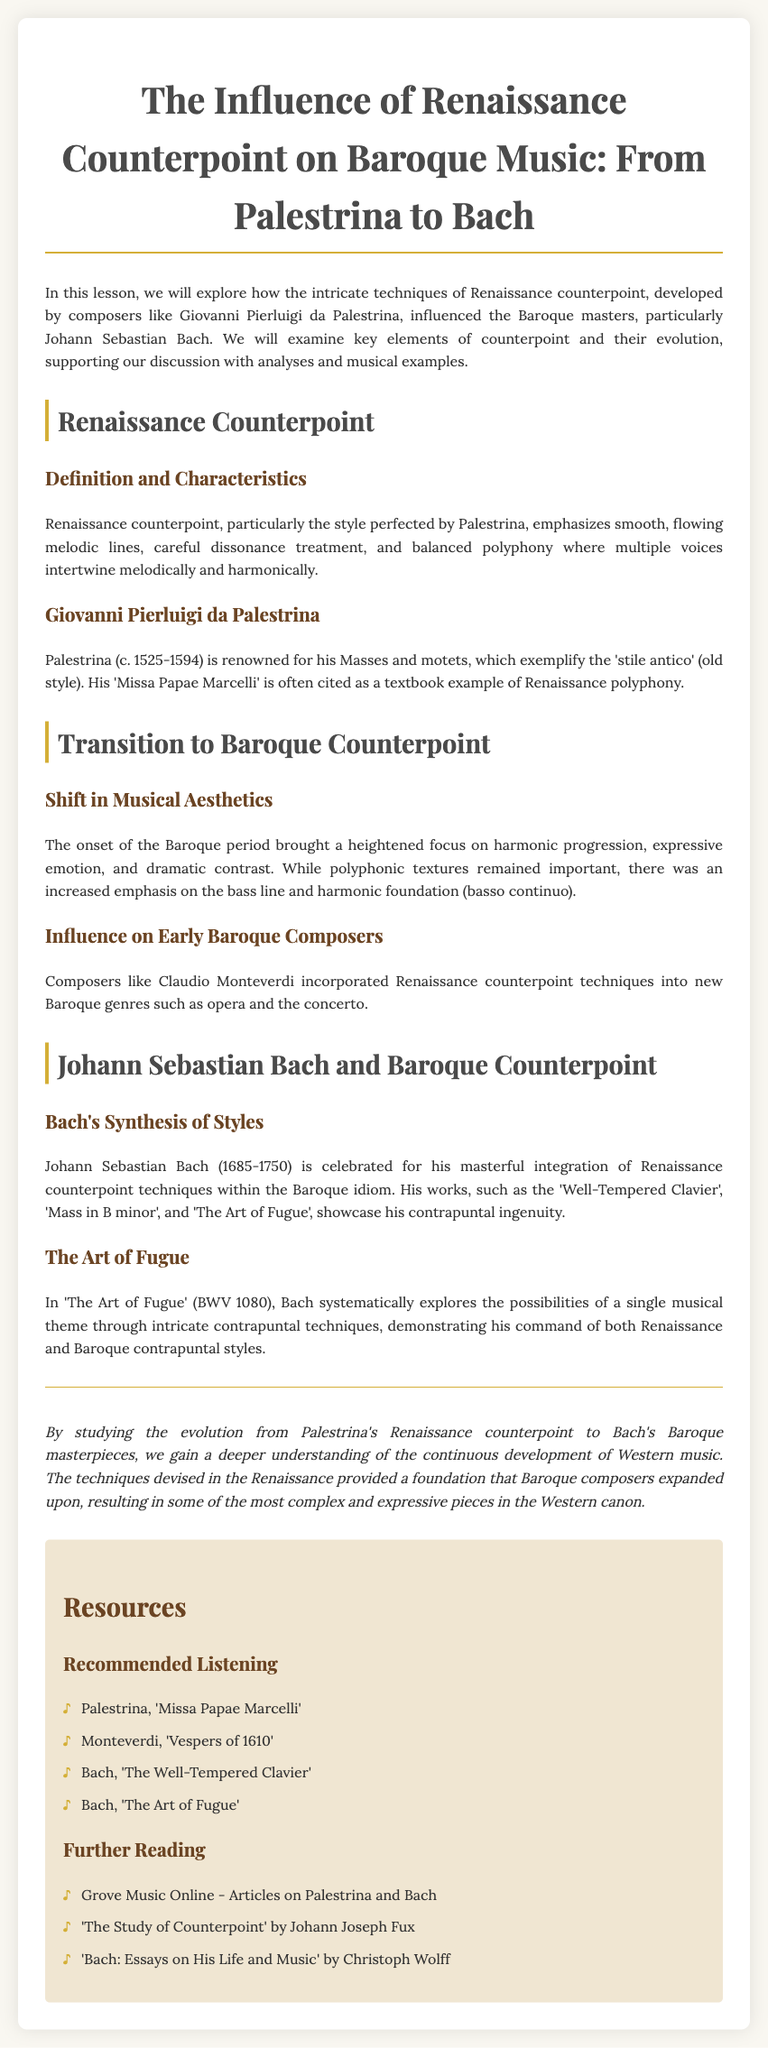What is the title of the lesson? The title of the lesson is provided at the top of the document, which outlines the topic being discussed.
Answer: The Influence of Renaissance Counterpoint on Baroque Music: From Palestrina to Bach Who is a notable composer associated with Renaissance counterpoint? The document mentions a specific composer known for his contributions to Renaissance counterpoint in the section about Renaissance counterpoint.
Answer: Giovanni Pierluigi da Palestrina What years did Johann Sebastian Bach live? The document specifies the years of Bach's life in the section discussing his contributions to Baroque counterpoint.
Answer: 1685-1750 What is the title of Palestrina's famous work mentioned? The document highlights a specific work by Palestrina as a textbook example within the context of Renaissance polyphony.
Answer: Missa Papae Marcelli Which Baroque composer is noted for integrating Renaissance counterpoint techniques? The lesson discusses a specific composer who is celebrated for this integration during the Baroque period.
Answer: Johann Sebastian Bach What is a key element emphasized in the transition to Baroque music? In the document, a specific aspect of Baroque music is highlighted as a departure from Renaissance practices.
Answer: Harmonic progression How does 'The Art of Fugue' demonstrate Bach's contrapuntal techniques? The lesson describes Bach’s exploration of a single musical theme through a specific method in 'The Art of Fugue'.
Answer: Intricate contrapuntal techniques Name one recommended listening piece from the resources section. The resources provide a list of compositions to explore further, highlighting specific music works related to the lesson.
Answer: Palestrina, 'Missa Papae Marcelli' What did composers like Monteverdi incorporate from Renaissance counterpoint? The lesson notes how early Baroque composers applied techniques from Renaissance to new genres, showing a particular integration.
Answer: Techniques of Renaissance counterpoint 